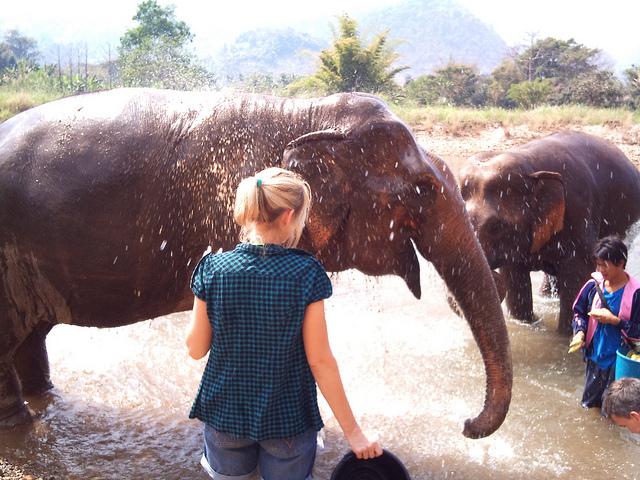Is the water muddy?
Write a very short answer. Yes. How many heads are visible here?
Be succinct. 4. How many elephants are there?
Be succinct. 2. 